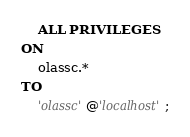<code> <loc_0><loc_0><loc_500><loc_500><_SQL_>    ALL PRIVILEGES
ON
    olassc.*
TO
    'olassc'@'localhost';
</code> 